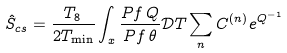Convert formula to latex. <formula><loc_0><loc_0><loc_500><loc_500>\hat { S } _ { c s } = \frac { T _ { 8 } } { 2 T _ { \min } } \int _ { x } \frac { P f \, Q } { P f \, \theta } { \mathcal { D } } T \sum _ { n } C ^ { ( n ) } e ^ { Q ^ { - 1 } }</formula> 